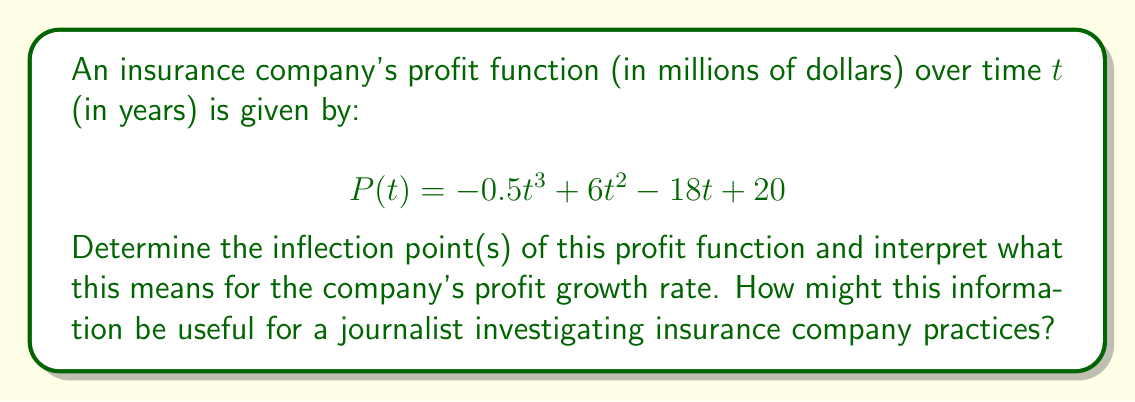Show me your answer to this math problem. To find the inflection point(s) of the profit function, we need to follow these steps:

1) First, calculate the first derivative of P(t):
   $$P'(t) = -1.5t^2 + 12t - 18$$

2) Then, calculate the second derivative:
   $$P''(t) = -3t + 12$$

3) The inflection point(s) occur where the second derivative equals zero:
   $$P''(t) = 0$$
   $$-3t + 12 = 0$$
   $$-3t = -12$$
   $$t = 4$$

4) To confirm this is an inflection point, we need to check if P''(t) changes sign around t = 4:
   For t < 4, P''(t) > 0
   For t > 4, P''(t) < 0

5) Now, we can calculate the profit at the inflection point:
   $$P(4) = -0.5(4)^3 + 6(4)^2 - 18(4) + 20 = 52$$ million dollars

Interpretation:
The inflection point occurs at t = 4 years, with a profit of $52 million. This point represents where the profit function changes from being concave up (accelerating growth) to concave down (decelerating growth).

For a journalist investigating insurance practices, this information is valuable because:
1) It shows when the company's profit growth rate peaks (at 4 years).
2) It indicates that after 4 years, the rate of profit growth starts to slow down, which might lead to changes in company practices or policy pricing.
3) The journalist could investigate what company practices or market conditions lead to this pattern of profit growth and subsequent slowdown.
Answer: The inflection point occurs at t = 4 years, with a profit of $52 million. This represents the point where the company's profit growth rate transitions from increasing to decreasing. 